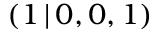<formula> <loc_0><loc_0><loc_500><loc_500>( 1 \, | \, 0 , 0 , 1 )</formula> 